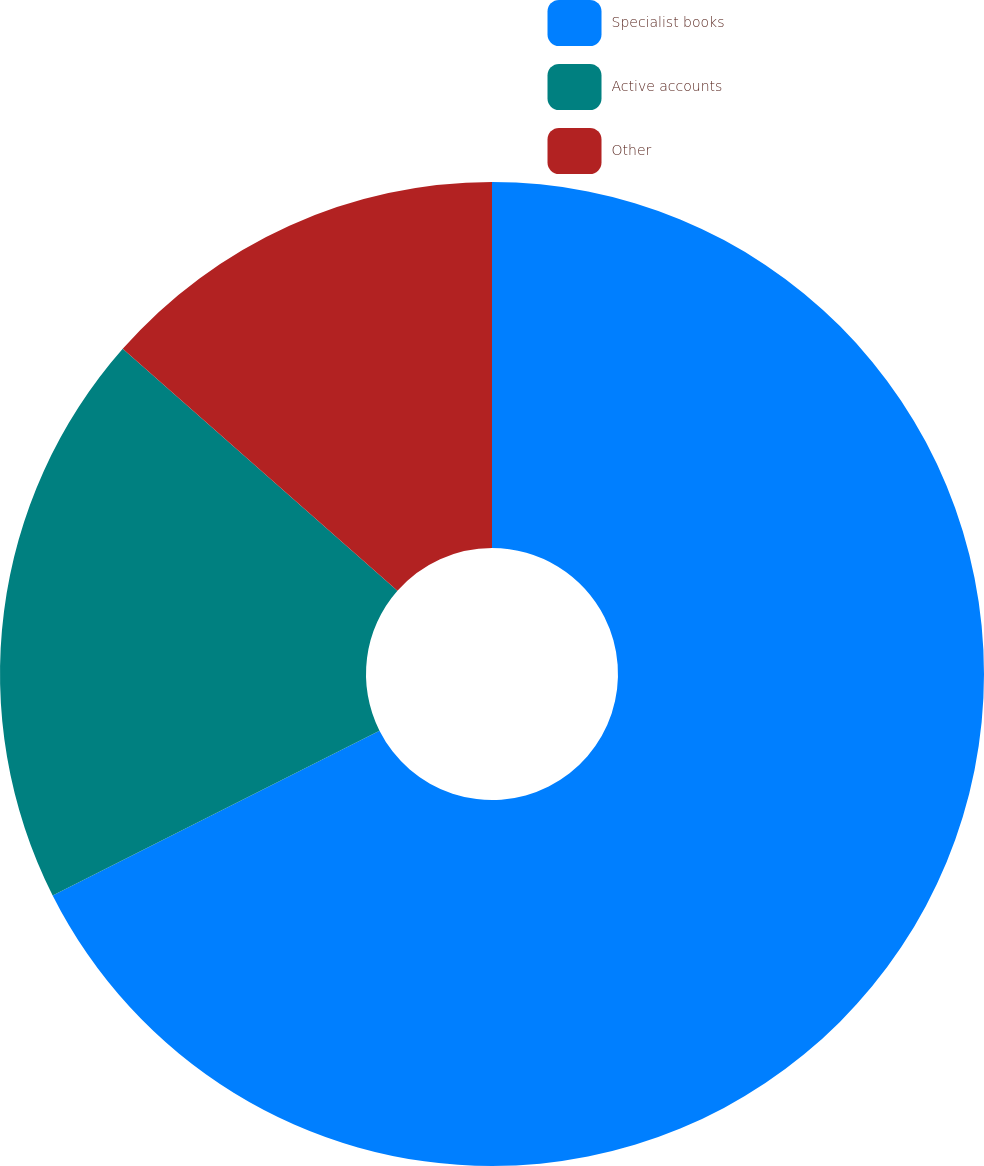Convert chart to OTSL. <chart><loc_0><loc_0><loc_500><loc_500><pie_chart><fcel>Specialist books<fcel>Active accounts<fcel>Other<nl><fcel>67.57%<fcel>18.92%<fcel>13.51%<nl></chart> 